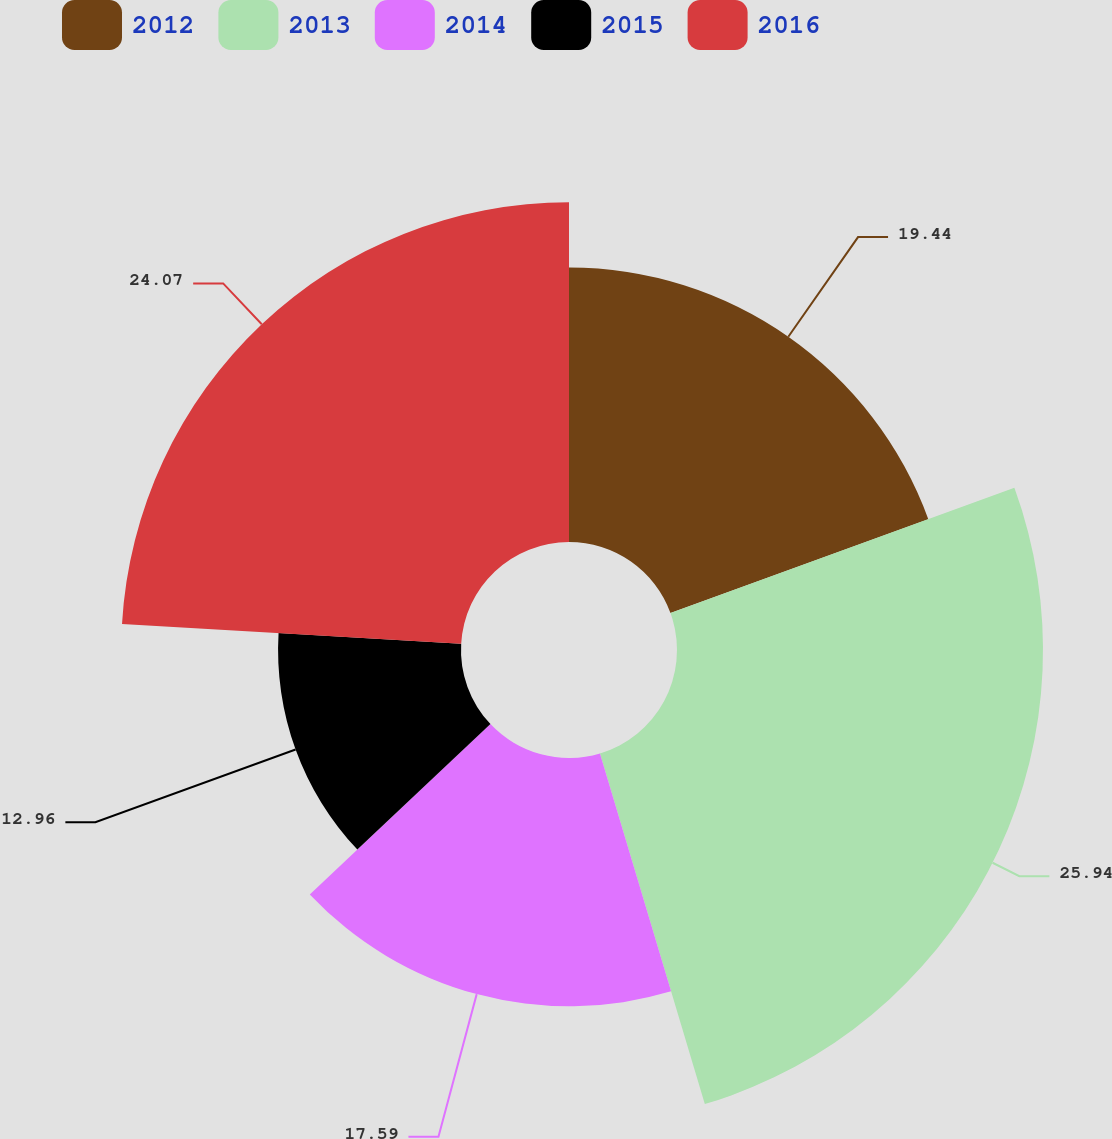Convert chart to OTSL. <chart><loc_0><loc_0><loc_500><loc_500><pie_chart><fcel>2012<fcel>2013<fcel>2014<fcel>2015<fcel>2016<nl><fcel>19.44%<fcel>25.93%<fcel>17.59%<fcel>12.96%<fcel>24.07%<nl></chart> 